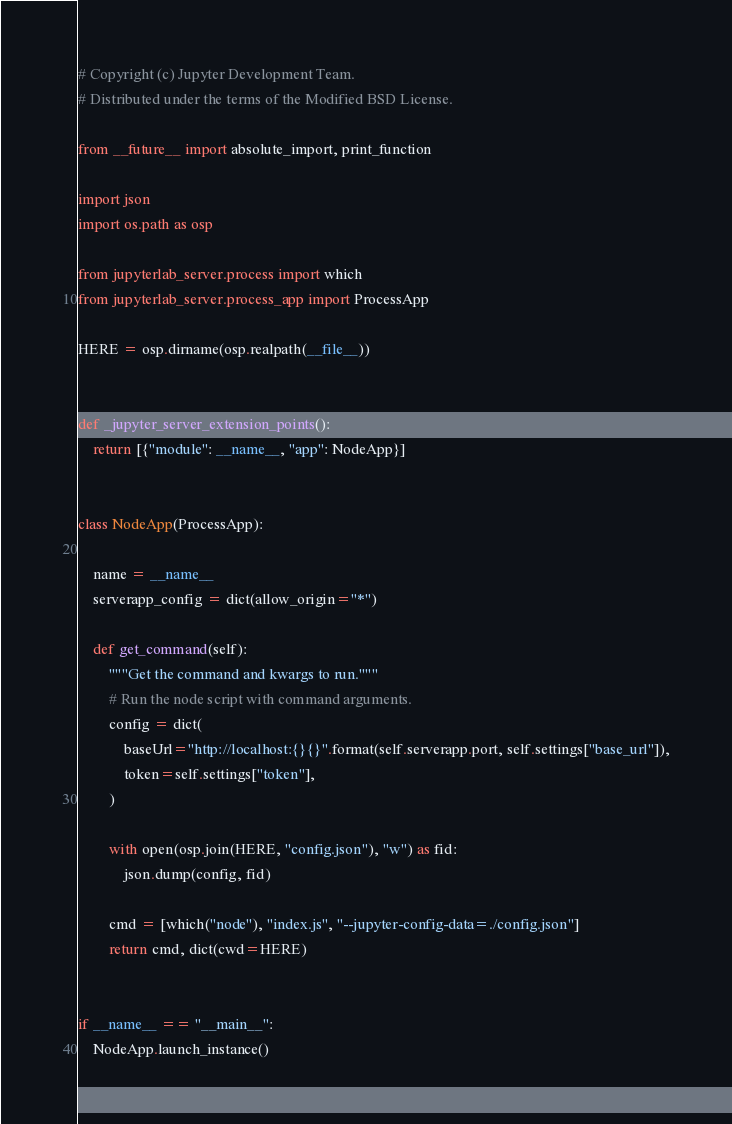<code> <loc_0><loc_0><loc_500><loc_500><_Python_># Copyright (c) Jupyter Development Team.
# Distributed under the terms of the Modified BSD License.

from __future__ import absolute_import, print_function

import json
import os.path as osp

from jupyterlab_server.process import which
from jupyterlab_server.process_app import ProcessApp

HERE = osp.dirname(osp.realpath(__file__))


def _jupyter_server_extension_points():
    return [{"module": __name__, "app": NodeApp}]


class NodeApp(ProcessApp):

    name = __name__
    serverapp_config = dict(allow_origin="*")

    def get_command(self):
        """Get the command and kwargs to run."""
        # Run the node script with command arguments.
        config = dict(
            baseUrl="http://localhost:{}{}".format(self.serverapp.port, self.settings["base_url"]),
            token=self.settings["token"],
        )

        with open(osp.join(HERE, "config.json"), "w") as fid:
            json.dump(config, fid)

        cmd = [which("node"), "index.js", "--jupyter-config-data=./config.json"]
        return cmd, dict(cwd=HERE)


if __name__ == "__main__":
    NodeApp.launch_instance()
</code> 